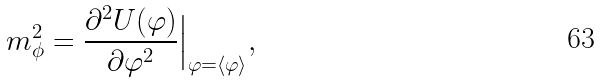<formula> <loc_0><loc_0><loc_500><loc_500>m _ { \phi } ^ { 2 } = \frac { \partial ^ { 2 } U ( \varphi ) } { \partial \varphi ^ { 2 } } \Big | _ { \varphi = \langle \varphi \rangle } ,</formula> 